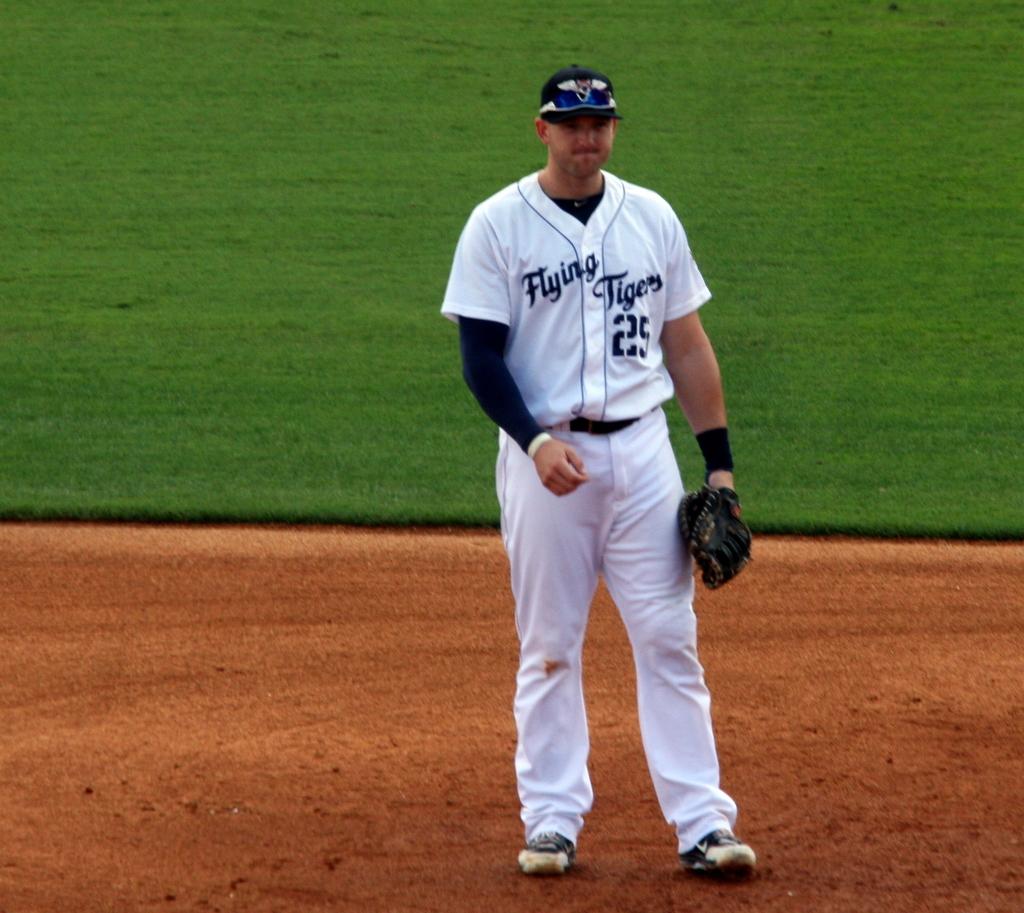What is this player's number?
Keep it short and to the point. 25. 